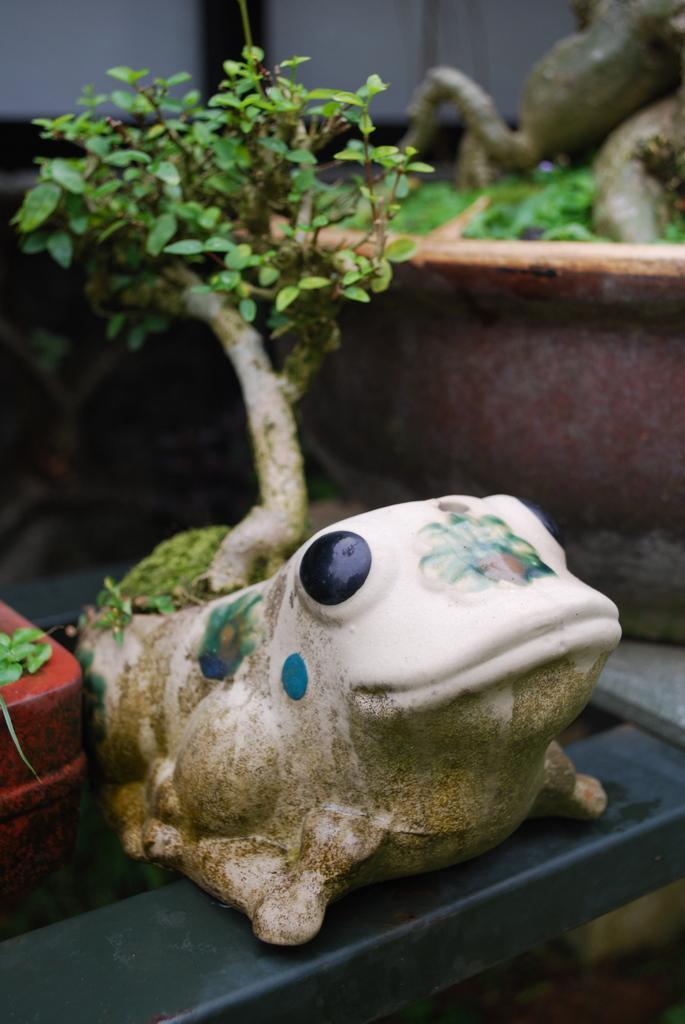Could you give a brief overview of what you see in this image? In the picture we can see some plant in a pot which is frog shaped and beside it, we can see other plants in a red color, substance and in the background also we can see some plant saplings. 